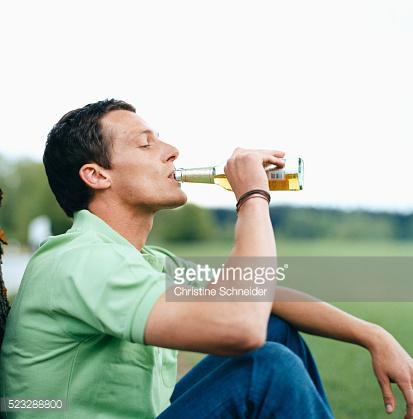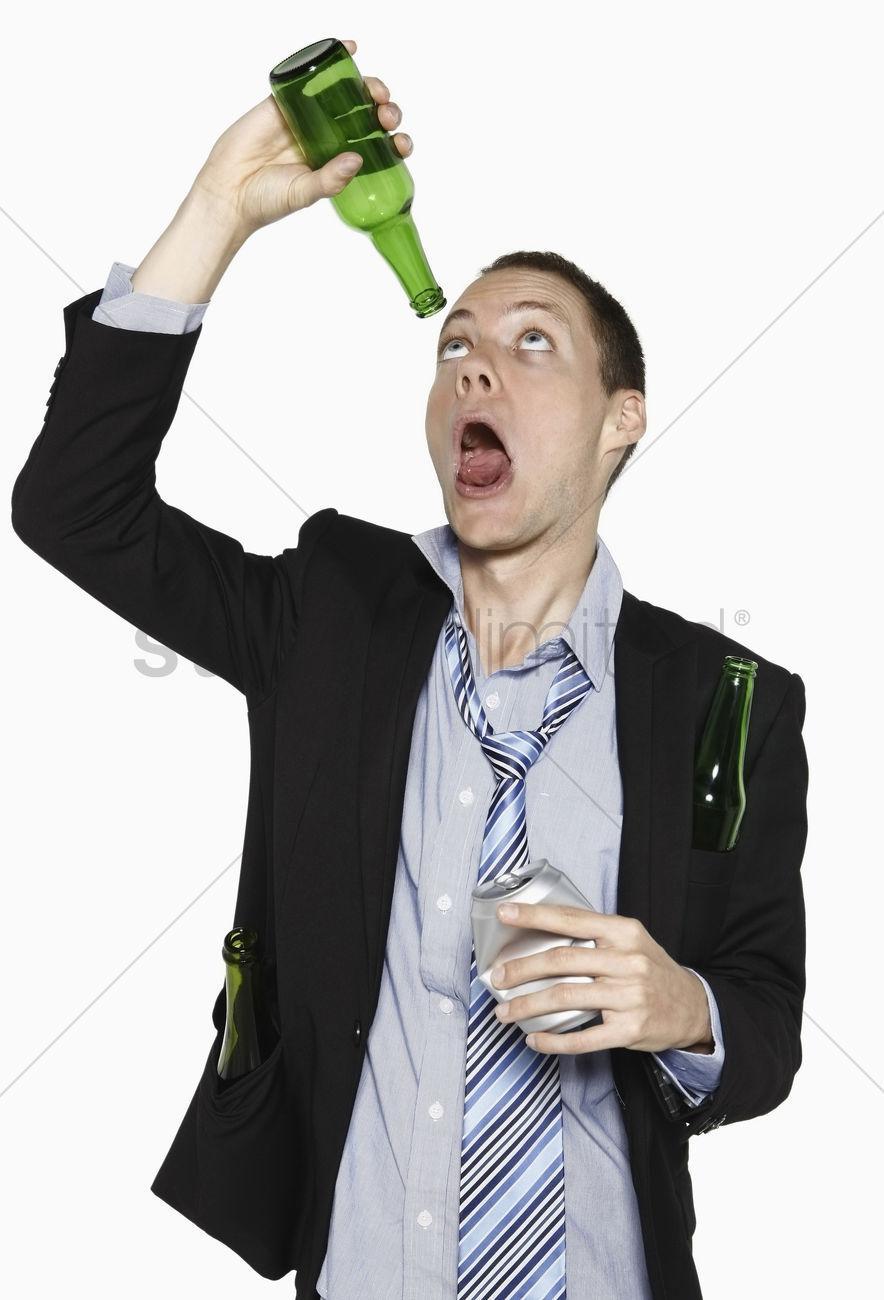The first image is the image on the left, the second image is the image on the right. Evaluate the accuracy of this statement regarding the images: "A person is holding a bottle above his open mouth.". Is it true? Answer yes or no. Yes. 